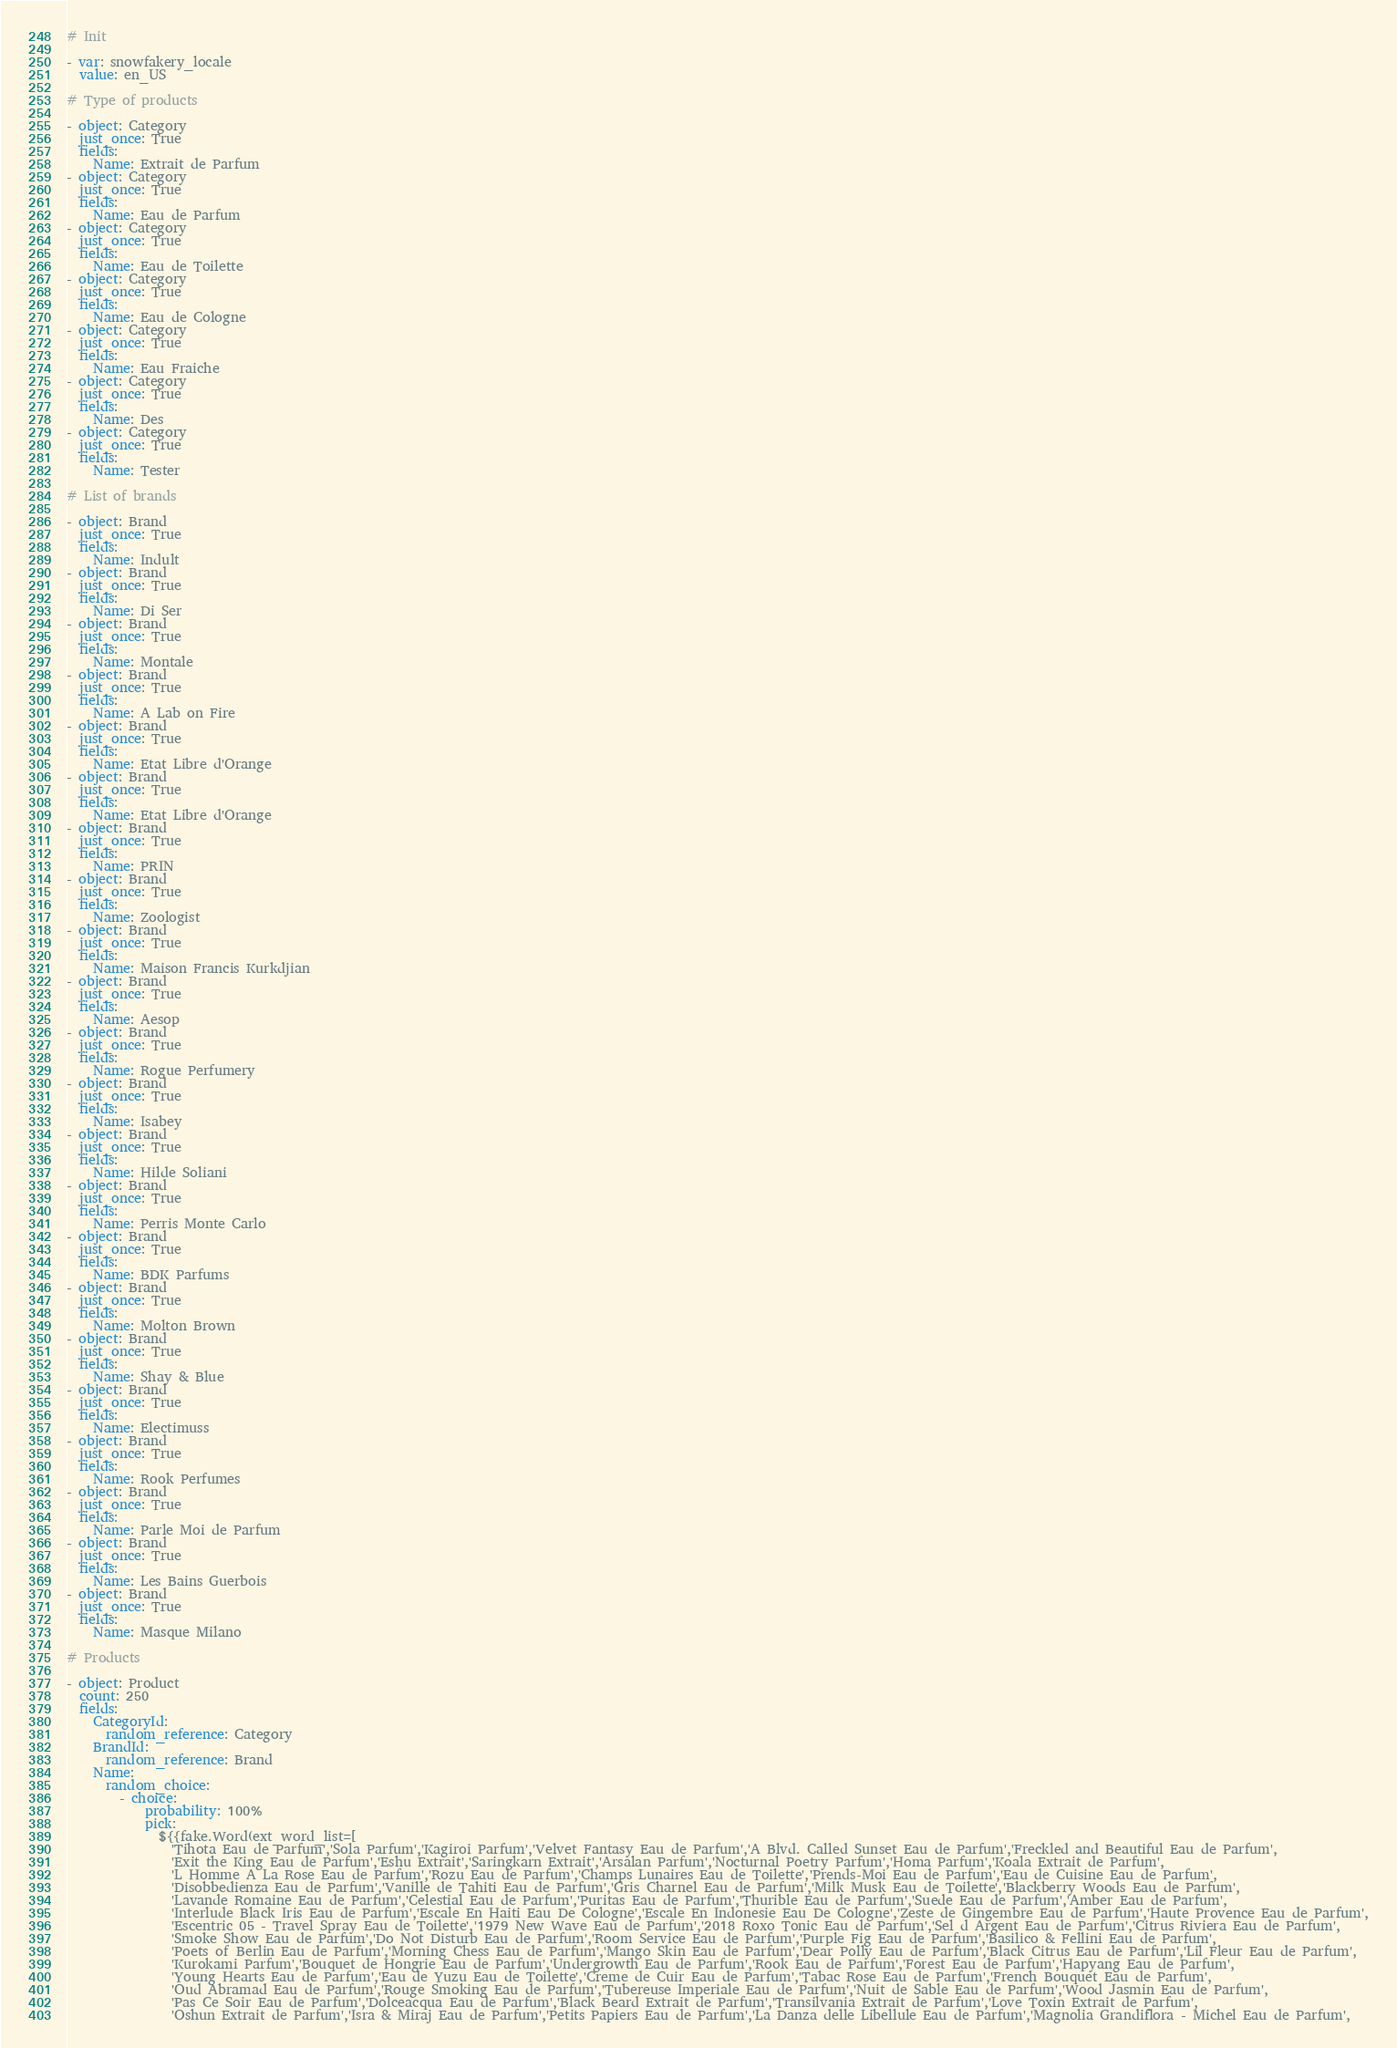<code> <loc_0><loc_0><loc_500><loc_500><_YAML_># Init

- var: snowfakery_locale
  value: en_US

# Type of products

- object: Category
  just_once: True
  fields:
    Name: Extrait de Parfum
- object: Category
  just_once: True
  fields:
    Name: Eau de Parfum
- object: Category
  just_once: True
  fields:
    Name: Eau de Toilette
- object: Category
  just_once: True
  fields:
    Name: Eau de Cologne
- object: Category
  just_once: True
  fields:
    Name: Eau Fraiche
- object: Category
  just_once: True
  fields:
    Name: Des
- object: Category
  just_once: True
  fields:
    Name: Tester

# List of brands

- object: Brand
  just_once: True
  fields:
    Name: Indult
- object: Brand
  just_once: True
  fields:
    Name: Di Ser
- object: Brand
  just_once: True
  fields:
    Name: Montale
- object: Brand
  just_once: True
  fields:
    Name: A Lab on Fire
- object: Brand
  just_once: True
  fields:
    Name: Etat Libre d'Orange
- object: Brand
  just_once: True
  fields:
    Name: Etat Libre d'Orange
- object: Brand
  just_once: True
  fields:
    Name: PRIN
- object: Brand
  just_once: True
  fields:
    Name: Zoologist
- object: Brand
  just_once: True
  fields:
    Name: Maison Francis Kurkdjian
- object: Brand
  just_once: True
  fields:
    Name: Aesop
- object: Brand
  just_once: True
  fields:
    Name: Rogue Perfumery
- object: Brand
  just_once: True
  fields:
    Name: Isabey
- object: Brand
  just_once: True
  fields:
    Name: Hilde Soliani
- object: Brand
  just_once: True
  fields:
    Name: Perris Monte Carlo
- object: Brand
  just_once: True
  fields:
    Name: BDK Parfums
- object: Brand
  just_once: True
  fields:
    Name: Molton Brown
- object: Brand
  just_once: True
  fields:
    Name: Shay & Blue
- object: Brand
  just_once: True
  fields:
    Name: Electimuss
- object: Brand
  just_once: True
  fields:
    Name: Rook Perfumes
- object: Brand
  just_once: True
  fields:
    Name: Parle Moi de Parfum
- object: Brand
  just_once: True
  fields:
    Name: Les Bains Guerbois
- object: Brand
  just_once: True
  fields:
    Name: Masque Milano

# Products

- object: Product
  count: 250
  fields:
    CategoryId:
      random_reference: Category
    BrandId:
      random_reference: Brand
    Name:
      random_choice:
        - choice:
            probability: 100%
            pick:
              ${{fake.Word(ext_word_list=[
                'Tihota Eau de Parfum','Sola Parfum','Kagiroi Parfum','Velvet Fantasy Eau de Parfum','A Blvd. Called Sunset Eau de Parfum','Freckled and Beautiful Eau de Parfum',
                'Exit the King Eau de Parfum','Eshu Extrait','Saringkarn Extrait','Arsalan Parfum','Nocturnal Poetry Parfum','Homa Parfum','Koala Extrait de Parfum',
                'L Homme A La Rose Eau de Parfum','Rozu Eau de Parfum','Champs Lunaires Eau de Toilette','Prends-Moi Eau de Parfum','Eau de Cuisine Eau de Parfum',
                'Disobbedienza Eau de Parfum','Vanille de Tahiti Eau de Parfum','Gris Charnel Eau de Parfum','Milk Musk Eau de Toilette','Blackberry Woods Eau de Parfum',
                'Lavande Romaine Eau de Parfum','Celestial Eau de Parfum','Puritas Eau de Parfum','Thurible Eau de Parfum','Suede Eau de Parfum','Amber Eau de Parfum',
                'Interlude Black Iris Eau de Parfum','Escale En Haiti Eau De Cologne','Escale En Indonesie Eau De Cologne','Zeste de Gingembre Eau de Parfum','Haute Provence Eau de Parfum',
                'Escentric 05 - Travel Spray Eau de Toilette','1979 New Wave Eau de Parfum','2018 Roxo Tonic Eau de Parfum','Sel d Argent Eau de Parfum','Citrus Riviera Eau de Parfum',
                'Smoke Show Eau de Parfum','Do Not Disturb Eau de Parfum','Room Service Eau de Parfum','Purple Fig Eau de Parfum','Basilico & Fellini Eau de Parfum',
                'Poets of Berlin Eau de Parfum','Morning Chess Eau de Parfum','Mango Skin Eau de Parfum','Dear Polly Eau de Parfum','Black Citrus Eau de Parfum','Lil Fleur Eau de Parfum',
                'Kurokami Parfum','Bouquet de Hongrie Eau de Parfum','Undergrowth Eau de Parfum','Rook Eau de Parfum','Forest Eau de Parfum','Hapyang Eau de Parfum',
                'Young Hearts Eau de Parfum','Eau de Yuzu Eau de Toilette','Creme de Cuir Eau de Parfum','Tabac Rose Eau de Parfum','French Bouquet Eau de Parfum',
                'Oud Abramad Eau de Parfum','Rouge Smoking Eau de Parfum','Tubereuse Imperiale Eau de Parfum','Nuit de Sable Eau de Parfum','Wood Jasmin Eau de Parfum',
                'Pas Ce Soir Eau de Parfum','Dolceacqua Eau de Parfum','Black Beard Extrait de Parfum','Transilvania Extrait de Parfum','Love Toxin Extrait de Parfum',
                'Oshun Extrait de Parfum','Isra & Miraj Eau de Parfum','Petits Papiers Eau de Parfum','La Danza delle Libellule Eau de Parfum','Magnolia Grandiflora - Michel Eau de Parfum',</code> 